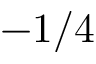Convert formula to latex. <formula><loc_0><loc_0><loc_500><loc_500>- 1 / 4</formula> 